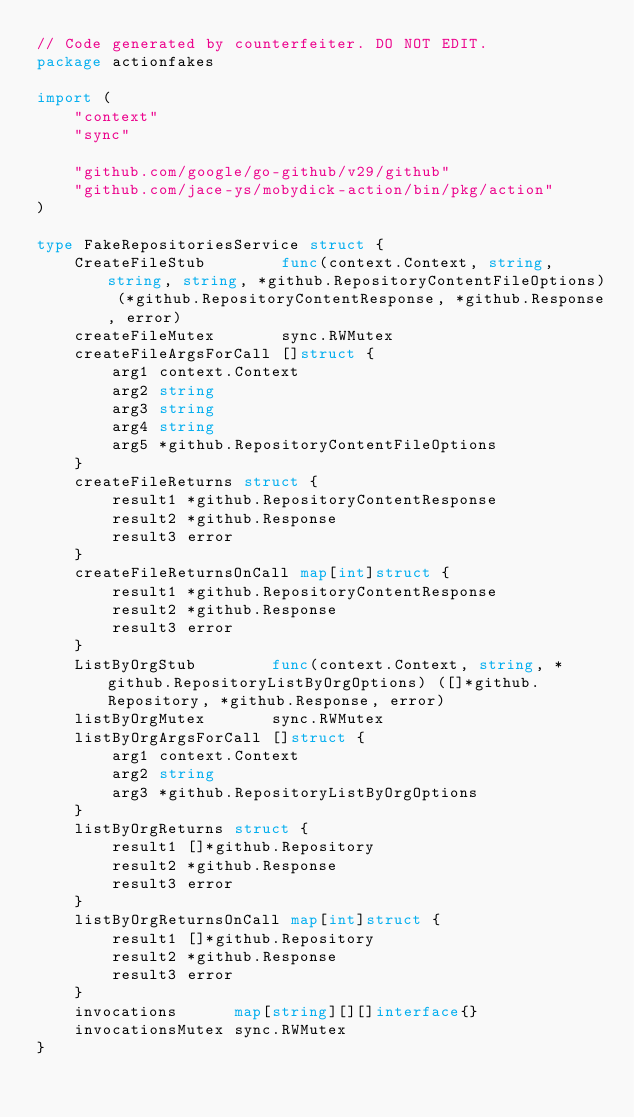<code> <loc_0><loc_0><loc_500><loc_500><_Go_>// Code generated by counterfeiter. DO NOT EDIT.
package actionfakes

import (
	"context"
	"sync"

	"github.com/google/go-github/v29/github"
	"github.com/jace-ys/mobydick-action/bin/pkg/action"
)

type FakeRepositoriesService struct {
	CreateFileStub        func(context.Context, string, string, string, *github.RepositoryContentFileOptions) (*github.RepositoryContentResponse, *github.Response, error)
	createFileMutex       sync.RWMutex
	createFileArgsForCall []struct {
		arg1 context.Context
		arg2 string
		arg3 string
		arg4 string
		arg5 *github.RepositoryContentFileOptions
	}
	createFileReturns struct {
		result1 *github.RepositoryContentResponse
		result2 *github.Response
		result3 error
	}
	createFileReturnsOnCall map[int]struct {
		result1 *github.RepositoryContentResponse
		result2 *github.Response
		result3 error
	}
	ListByOrgStub        func(context.Context, string, *github.RepositoryListByOrgOptions) ([]*github.Repository, *github.Response, error)
	listByOrgMutex       sync.RWMutex
	listByOrgArgsForCall []struct {
		arg1 context.Context
		arg2 string
		arg3 *github.RepositoryListByOrgOptions
	}
	listByOrgReturns struct {
		result1 []*github.Repository
		result2 *github.Response
		result3 error
	}
	listByOrgReturnsOnCall map[int]struct {
		result1 []*github.Repository
		result2 *github.Response
		result3 error
	}
	invocations      map[string][][]interface{}
	invocationsMutex sync.RWMutex
}
</code> 